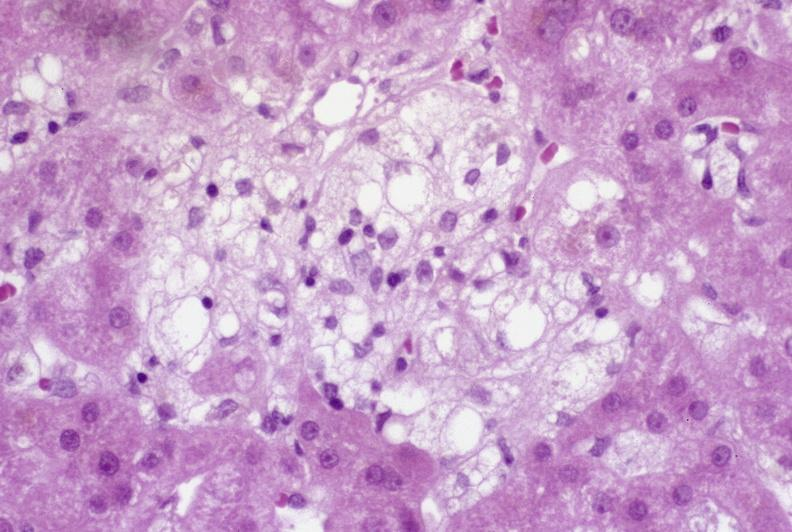what is present?
Answer the question using a single word or phrase. Hepatobiliary 